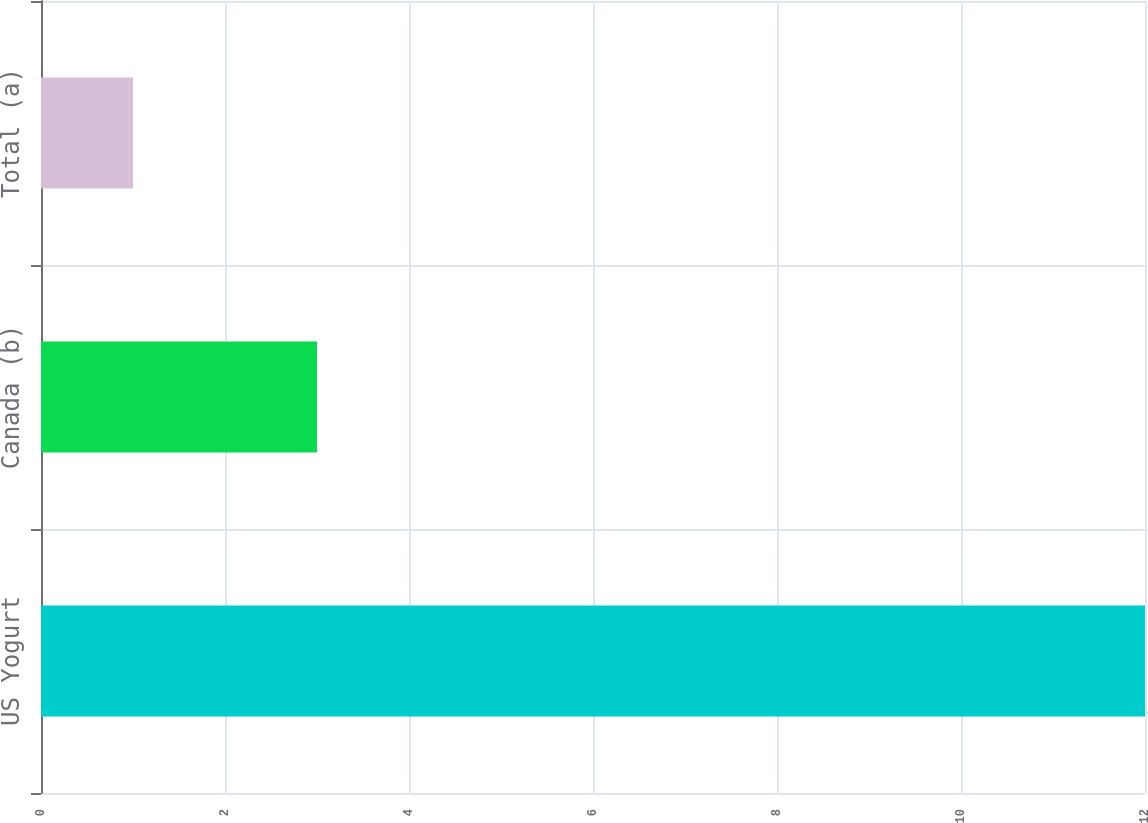Convert chart to OTSL. <chart><loc_0><loc_0><loc_500><loc_500><bar_chart><fcel>US Yogurt<fcel>Canada (b)<fcel>Total (a)<nl><fcel>12<fcel>3<fcel>1<nl></chart> 